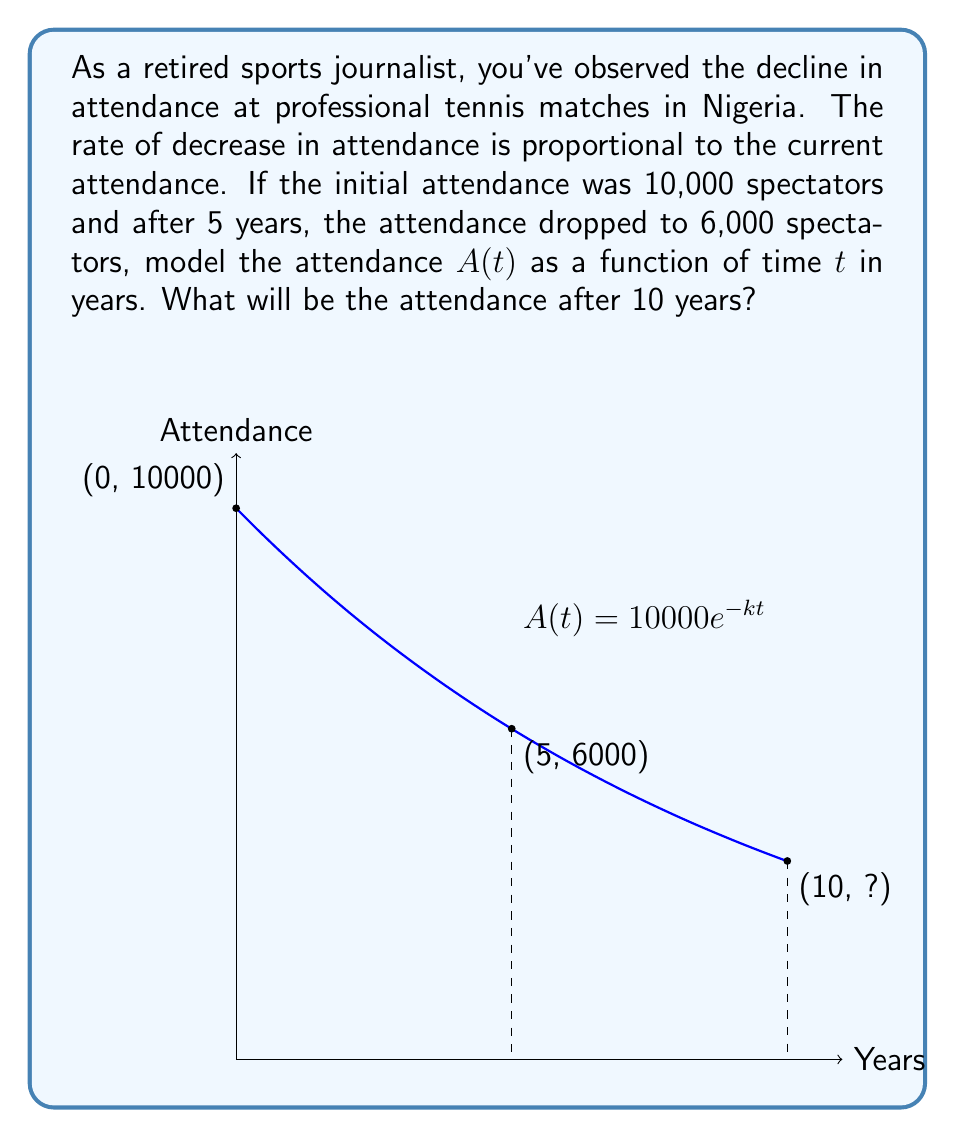Show me your answer to this math problem. Let's approach this step-by-step:

1) The rate of decrease is proportional to the current attendance. This can be modeled by the differential equation:

   $$\frac{dA}{dt} = -kA$$

   where $k$ is a positive constant.

2) The solution to this differential equation is:

   $$A(t) = A_0e^{-kt}$$

   where $A_0$ is the initial attendance.

3) We know that $A_0 = 10000$ and after 5 years, $A(5) = 6000$. Let's use these to find $k$:

   $$6000 = 10000e^{-5k}$$

4) Solving for $k$:

   $$\frac{6000}{10000} = e^{-5k}$$
   $$0.6 = e^{-5k}$$
   $$\ln(0.6) = -5k$$
   $$k = -\frac{\ln(0.6)}{5} \approx 0.1023$$

5) Now we have our complete model:

   $$A(t) = 10000e^{-0.1023t}$$

6) To find the attendance after 10 years, we simply plug in $t = 10$:

   $$A(10) = 10000e^{-0.1023 \cdot 10} \approx 3600.44$$
Answer: $3600$ spectators (rounded to the nearest whole number) 